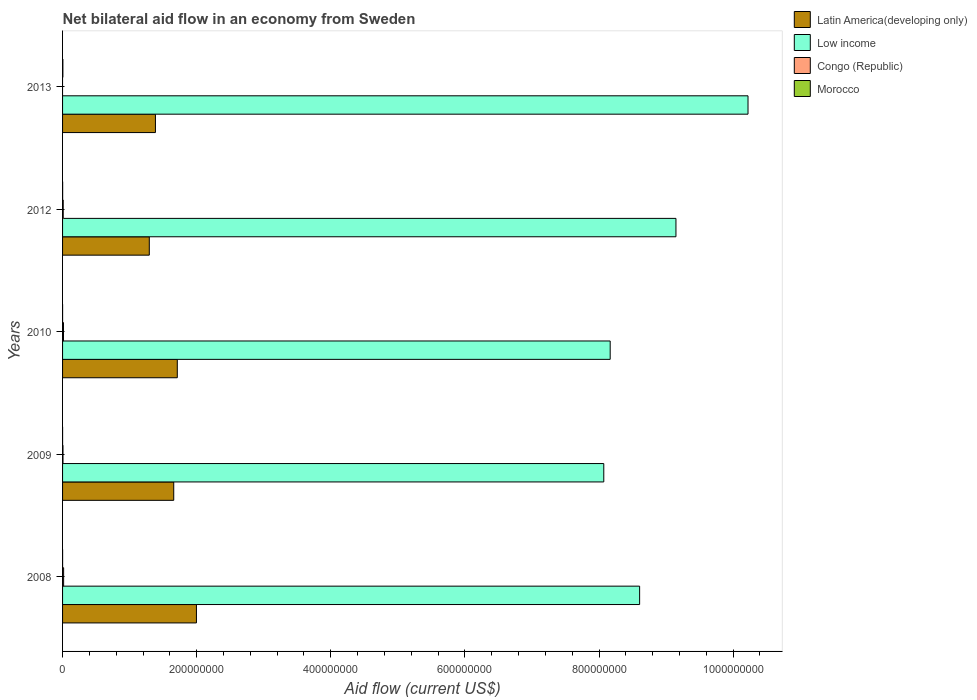How many different coloured bars are there?
Your response must be concise. 4. What is the label of the 4th group of bars from the top?
Provide a short and direct response. 2009. What is the net bilateral aid flow in Latin America(developing only) in 2010?
Offer a very short reply. 1.71e+08. Across all years, what is the maximum net bilateral aid flow in Latin America(developing only)?
Provide a short and direct response. 2.00e+08. Across all years, what is the minimum net bilateral aid flow in Latin America(developing only)?
Make the answer very short. 1.29e+08. What is the total net bilateral aid flow in Low income in the graph?
Your answer should be very brief. 4.42e+09. What is the difference between the net bilateral aid flow in Latin America(developing only) in 2009 and that in 2012?
Provide a short and direct response. 3.65e+07. What is the difference between the net bilateral aid flow in Congo (Republic) in 2010 and the net bilateral aid flow in Low income in 2012?
Your response must be concise. -9.13e+08. What is the average net bilateral aid flow in Congo (Republic) per year?
Make the answer very short. 9.08e+05. In the year 2008, what is the difference between the net bilateral aid flow in Congo (Republic) and net bilateral aid flow in Morocco?
Offer a terse response. 1.54e+06. What is the ratio of the net bilateral aid flow in Low income in 2009 to that in 2013?
Provide a succinct answer. 0.79. What is the difference between the highest and the lowest net bilateral aid flow in Morocco?
Offer a very short reply. 4.40e+05. In how many years, is the net bilateral aid flow in Low income greater than the average net bilateral aid flow in Low income taken over all years?
Your answer should be very brief. 2. How many bars are there?
Give a very brief answer. 19. What is the difference between two consecutive major ticks on the X-axis?
Keep it short and to the point. 2.00e+08. Does the graph contain any zero values?
Your answer should be very brief. Yes. Does the graph contain grids?
Your answer should be very brief. No. How are the legend labels stacked?
Ensure brevity in your answer.  Vertical. What is the title of the graph?
Make the answer very short. Net bilateral aid flow in an economy from Sweden. What is the Aid flow (current US$) in Latin America(developing only) in 2008?
Offer a terse response. 2.00e+08. What is the Aid flow (current US$) of Low income in 2008?
Your response must be concise. 8.61e+08. What is the Aid flow (current US$) in Congo (Republic) in 2008?
Ensure brevity in your answer.  1.57e+06. What is the Aid flow (current US$) of Latin America(developing only) in 2009?
Your answer should be compact. 1.66e+08. What is the Aid flow (current US$) in Low income in 2009?
Make the answer very short. 8.07e+08. What is the Aid flow (current US$) in Congo (Republic) in 2009?
Provide a short and direct response. 6.20e+05. What is the Aid flow (current US$) in Latin America(developing only) in 2010?
Provide a succinct answer. 1.71e+08. What is the Aid flow (current US$) of Low income in 2010?
Ensure brevity in your answer.  8.17e+08. What is the Aid flow (current US$) of Congo (Republic) in 2010?
Your response must be concise. 1.38e+06. What is the Aid flow (current US$) in Latin America(developing only) in 2012?
Keep it short and to the point. 1.29e+08. What is the Aid flow (current US$) in Low income in 2012?
Keep it short and to the point. 9.15e+08. What is the Aid flow (current US$) of Congo (Republic) in 2012?
Provide a short and direct response. 9.70e+05. What is the Aid flow (current US$) in Morocco in 2012?
Offer a terse response. 1.10e+05. What is the Aid flow (current US$) of Latin America(developing only) in 2013?
Your response must be concise. 1.38e+08. What is the Aid flow (current US$) in Low income in 2013?
Make the answer very short. 1.02e+09. Across all years, what is the maximum Aid flow (current US$) in Latin America(developing only)?
Your answer should be very brief. 2.00e+08. Across all years, what is the maximum Aid flow (current US$) in Low income?
Give a very brief answer. 1.02e+09. Across all years, what is the maximum Aid flow (current US$) in Congo (Republic)?
Your response must be concise. 1.57e+06. Across all years, what is the maximum Aid flow (current US$) of Morocco?
Your answer should be compact. 4.50e+05. Across all years, what is the minimum Aid flow (current US$) of Latin America(developing only)?
Provide a short and direct response. 1.29e+08. Across all years, what is the minimum Aid flow (current US$) in Low income?
Give a very brief answer. 8.07e+08. Across all years, what is the minimum Aid flow (current US$) of Morocco?
Your response must be concise. 10000. What is the total Aid flow (current US$) in Latin America(developing only) in the graph?
Give a very brief answer. 8.04e+08. What is the total Aid flow (current US$) of Low income in the graph?
Offer a terse response. 4.42e+09. What is the total Aid flow (current US$) of Congo (Republic) in the graph?
Make the answer very short. 4.54e+06. What is the total Aid flow (current US$) of Morocco in the graph?
Make the answer very short. 6.20e+05. What is the difference between the Aid flow (current US$) in Latin America(developing only) in 2008 and that in 2009?
Your answer should be compact. 3.38e+07. What is the difference between the Aid flow (current US$) in Low income in 2008 and that in 2009?
Provide a succinct answer. 5.34e+07. What is the difference between the Aid flow (current US$) in Congo (Republic) in 2008 and that in 2009?
Your answer should be compact. 9.50e+05. What is the difference between the Aid flow (current US$) of Latin America(developing only) in 2008 and that in 2010?
Offer a terse response. 2.85e+07. What is the difference between the Aid flow (current US$) in Low income in 2008 and that in 2010?
Your answer should be compact. 4.39e+07. What is the difference between the Aid flow (current US$) in Congo (Republic) in 2008 and that in 2010?
Give a very brief answer. 1.90e+05. What is the difference between the Aid flow (current US$) in Latin America(developing only) in 2008 and that in 2012?
Offer a very short reply. 7.03e+07. What is the difference between the Aid flow (current US$) of Low income in 2008 and that in 2012?
Your response must be concise. -5.42e+07. What is the difference between the Aid flow (current US$) in Congo (Republic) in 2008 and that in 2012?
Your response must be concise. 6.00e+05. What is the difference between the Aid flow (current US$) of Latin America(developing only) in 2008 and that in 2013?
Provide a short and direct response. 6.11e+07. What is the difference between the Aid flow (current US$) of Low income in 2008 and that in 2013?
Your answer should be very brief. -1.62e+08. What is the difference between the Aid flow (current US$) in Morocco in 2008 and that in 2013?
Provide a succinct answer. -4.20e+05. What is the difference between the Aid flow (current US$) in Latin America(developing only) in 2009 and that in 2010?
Keep it short and to the point. -5.31e+06. What is the difference between the Aid flow (current US$) in Low income in 2009 and that in 2010?
Make the answer very short. -9.55e+06. What is the difference between the Aid flow (current US$) in Congo (Republic) in 2009 and that in 2010?
Your response must be concise. -7.60e+05. What is the difference between the Aid flow (current US$) in Morocco in 2009 and that in 2010?
Make the answer very short. -10000. What is the difference between the Aid flow (current US$) in Latin America(developing only) in 2009 and that in 2012?
Provide a succinct answer. 3.65e+07. What is the difference between the Aid flow (current US$) in Low income in 2009 and that in 2012?
Offer a terse response. -1.08e+08. What is the difference between the Aid flow (current US$) of Congo (Republic) in 2009 and that in 2012?
Your response must be concise. -3.50e+05. What is the difference between the Aid flow (current US$) of Morocco in 2009 and that in 2012?
Make the answer very short. -1.00e+05. What is the difference between the Aid flow (current US$) in Latin America(developing only) in 2009 and that in 2013?
Your answer should be very brief. 2.73e+07. What is the difference between the Aid flow (current US$) in Low income in 2009 and that in 2013?
Provide a succinct answer. -2.15e+08. What is the difference between the Aid flow (current US$) of Morocco in 2009 and that in 2013?
Keep it short and to the point. -4.40e+05. What is the difference between the Aid flow (current US$) in Latin America(developing only) in 2010 and that in 2012?
Keep it short and to the point. 4.18e+07. What is the difference between the Aid flow (current US$) in Low income in 2010 and that in 2012?
Offer a very short reply. -9.81e+07. What is the difference between the Aid flow (current US$) in Congo (Republic) in 2010 and that in 2012?
Offer a terse response. 4.10e+05. What is the difference between the Aid flow (current US$) in Morocco in 2010 and that in 2012?
Your answer should be very brief. -9.00e+04. What is the difference between the Aid flow (current US$) of Latin America(developing only) in 2010 and that in 2013?
Provide a short and direct response. 3.26e+07. What is the difference between the Aid flow (current US$) of Low income in 2010 and that in 2013?
Your answer should be very brief. -2.06e+08. What is the difference between the Aid flow (current US$) in Morocco in 2010 and that in 2013?
Give a very brief answer. -4.30e+05. What is the difference between the Aid flow (current US$) in Latin America(developing only) in 2012 and that in 2013?
Ensure brevity in your answer.  -9.17e+06. What is the difference between the Aid flow (current US$) of Low income in 2012 and that in 2013?
Your answer should be compact. -1.07e+08. What is the difference between the Aid flow (current US$) in Latin America(developing only) in 2008 and the Aid flow (current US$) in Low income in 2009?
Make the answer very short. -6.07e+08. What is the difference between the Aid flow (current US$) of Latin America(developing only) in 2008 and the Aid flow (current US$) of Congo (Republic) in 2009?
Offer a terse response. 1.99e+08. What is the difference between the Aid flow (current US$) in Latin America(developing only) in 2008 and the Aid flow (current US$) in Morocco in 2009?
Keep it short and to the point. 2.00e+08. What is the difference between the Aid flow (current US$) in Low income in 2008 and the Aid flow (current US$) in Congo (Republic) in 2009?
Give a very brief answer. 8.60e+08. What is the difference between the Aid flow (current US$) in Low income in 2008 and the Aid flow (current US$) in Morocco in 2009?
Provide a succinct answer. 8.61e+08. What is the difference between the Aid flow (current US$) in Congo (Republic) in 2008 and the Aid flow (current US$) in Morocco in 2009?
Give a very brief answer. 1.56e+06. What is the difference between the Aid flow (current US$) in Latin America(developing only) in 2008 and the Aid flow (current US$) in Low income in 2010?
Your answer should be very brief. -6.17e+08. What is the difference between the Aid flow (current US$) of Latin America(developing only) in 2008 and the Aid flow (current US$) of Congo (Republic) in 2010?
Your answer should be compact. 1.98e+08. What is the difference between the Aid flow (current US$) in Latin America(developing only) in 2008 and the Aid flow (current US$) in Morocco in 2010?
Offer a very short reply. 2.00e+08. What is the difference between the Aid flow (current US$) of Low income in 2008 and the Aid flow (current US$) of Congo (Republic) in 2010?
Your answer should be compact. 8.59e+08. What is the difference between the Aid flow (current US$) of Low income in 2008 and the Aid flow (current US$) of Morocco in 2010?
Your answer should be compact. 8.61e+08. What is the difference between the Aid flow (current US$) of Congo (Republic) in 2008 and the Aid flow (current US$) of Morocco in 2010?
Provide a succinct answer. 1.55e+06. What is the difference between the Aid flow (current US$) in Latin America(developing only) in 2008 and the Aid flow (current US$) in Low income in 2012?
Give a very brief answer. -7.15e+08. What is the difference between the Aid flow (current US$) of Latin America(developing only) in 2008 and the Aid flow (current US$) of Congo (Republic) in 2012?
Provide a succinct answer. 1.99e+08. What is the difference between the Aid flow (current US$) of Latin America(developing only) in 2008 and the Aid flow (current US$) of Morocco in 2012?
Offer a terse response. 2.00e+08. What is the difference between the Aid flow (current US$) in Low income in 2008 and the Aid flow (current US$) in Congo (Republic) in 2012?
Offer a very short reply. 8.60e+08. What is the difference between the Aid flow (current US$) of Low income in 2008 and the Aid flow (current US$) of Morocco in 2012?
Provide a succinct answer. 8.60e+08. What is the difference between the Aid flow (current US$) of Congo (Republic) in 2008 and the Aid flow (current US$) of Morocco in 2012?
Offer a terse response. 1.46e+06. What is the difference between the Aid flow (current US$) of Latin America(developing only) in 2008 and the Aid flow (current US$) of Low income in 2013?
Ensure brevity in your answer.  -8.23e+08. What is the difference between the Aid flow (current US$) of Latin America(developing only) in 2008 and the Aid flow (current US$) of Morocco in 2013?
Provide a short and direct response. 1.99e+08. What is the difference between the Aid flow (current US$) of Low income in 2008 and the Aid flow (current US$) of Morocco in 2013?
Your answer should be very brief. 8.60e+08. What is the difference between the Aid flow (current US$) of Congo (Republic) in 2008 and the Aid flow (current US$) of Morocco in 2013?
Provide a succinct answer. 1.12e+06. What is the difference between the Aid flow (current US$) of Latin America(developing only) in 2009 and the Aid flow (current US$) of Low income in 2010?
Offer a very short reply. -6.51e+08. What is the difference between the Aid flow (current US$) of Latin America(developing only) in 2009 and the Aid flow (current US$) of Congo (Republic) in 2010?
Your answer should be compact. 1.64e+08. What is the difference between the Aid flow (current US$) of Latin America(developing only) in 2009 and the Aid flow (current US$) of Morocco in 2010?
Offer a very short reply. 1.66e+08. What is the difference between the Aid flow (current US$) in Low income in 2009 and the Aid flow (current US$) in Congo (Republic) in 2010?
Give a very brief answer. 8.06e+08. What is the difference between the Aid flow (current US$) in Low income in 2009 and the Aid flow (current US$) in Morocco in 2010?
Ensure brevity in your answer.  8.07e+08. What is the difference between the Aid flow (current US$) in Congo (Republic) in 2009 and the Aid flow (current US$) in Morocco in 2010?
Ensure brevity in your answer.  6.00e+05. What is the difference between the Aid flow (current US$) of Latin America(developing only) in 2009 and the Aid flow (current US$) of Low income in 2012?
Offer a terse response. -7.49e+08. What is the difference between the Aid flow (current US$) in Latin America(developing only) in 2009 and the Aid flow (current US$) in Congo (Republic) in 2012?
Offer a very short reply. 1.65e+08. What is the difference between the Aid flow (current US$) in Latin America(developing only) in 2009 and the Aid flow (current US$) in Morocco in 2012?
Your response must be concise. 1.66e+08. What is the difference between the Aid flow (current US$) in Low income in 2009 and the Aid flow (current US$) in Congo (Republic) in 2012?
Make the answer very short. 8.06e+08. What is the difference between the Aid flow (current US$) of Low income in 2009 and the Aid flow (current US$) of Morocco in 2012?
Provide a short and direct response. 8.07e+08. What is the difference between the Aid flow (current US$) of Congo (Republic) in 2009 and the Aid flow (current US$) of Morocco in 2012?
Provide a short and direct response. 5.10e+05. What is the difference between the Aid flow (current US$) in Latin America(developing only) in 2009 and the Aid flow (current US$) in Low income in 2013?
Offer a very short reply. -8.56e+08. What is the difference between the Aid flow (current US$) of Latin America(developing only) in 2009 and the Aid flow (current US$) of Morocco in 2013?
Offer a very short reply. 1.65e+08. What is the difference between the Aid flow (current US$) in Low income in 2009 and the Aid flow (current US$) in Morocco in 2013?
Offer a terse response. 8.07e+08. What is the difference between the Aid flow (current US$) of Congo (Republic) in 2009 and the Aid flow (current US$) of Morocco in 2013?
Make the answer very short. 1.70e+05. What is the difference between the Aid flow (current US$) of Latin America(developing only) in 2010 and the Aid flow (current US$) of Low income in 2012?
Give a very brief answer. -7.44e+08. What is the difference between the Aid flow (current US$) of Latin America(developing only) in 2010 and the Aid flow (current US$) of Congo (Republic) in 2012?
Your answer should be compact. 1.70e+08. What is the difference between the Aid flow (current US$) in Latin America(developing only) in 2010 and the Aid flow (current US$) in Morocco in 2012?
Provide a succinct answer. 1.71e+08. What is the difference between the Aid flow (current US$) of Low income in 2010 and the Aid flow (current US$) of Congo (Republic) in 2012?
Your answer should be compact. 8.16e+08. What is the difference between the Aid flow (current US$) in Low income in 2010 and the Aid flow (current US$) in Morocco in 2012?
Keep it short and to the point. 8.17e+08. What is the difference between the Aid flow (current US$) in Congo (Republic) in 2010 and the Aid flow (current US$) in Morocco in 2012?
Your answer should be compact. 1.27e+06. What is the difference between the Aid flow (current US$) in Latin America(developing only) in 2010 and the Aid flow (current US$) in Low income in 2013?
Your answer should be compact. -8.51e+08. What is the difference between the Aid flow (current US$) in Latin America(developing only) in 2010 and the Aid flow (current US$) in Morocco in 2013?
Your answer should be compact. 1.71e+08. What is the difference between the Aid flow (current US$) in Low income in 2010 and the Aid flow (current US$) in Morocco in 2013?
Offer a terse response. 8.16e+08. What is the difference between the Aid flow (current US$) in Congo (Republic) in 2010 and the Aid flow (current US$) in Morocco in 2013?
Provide a succinct answer. 9.30e+05. What is the difference between the Aid flow (current US$) of Latin America(developing only) in 2012 and the Aid flow (current US$) of Low income in 2013?
Offer a very short reply. -8.93e+08. What is the difference between the Aid flow (current US$) of Latin America(developing only) in 2012 and the Aid flow (current US$) of Morocco in 2013?
Your response must be concise. 1.29e+08. What is the difference between the Aid flow (current US$) of Low income in 2012 and the Aid flow (current US$) of Morocco in 2013?
Give a very brief answer. 9.14e+08. What is the difference between the Aid flow (current US$) in Congo (Republic) in 2012 and the Aid flow (current US$) in Morocco in 2013?
Ensure brevity in your answer.  5.20e+05. What is the average Aid flow (current US$) in Latin America(developing only) per year?
Your response must be concise. 1.61e+08. What is the average Aid flow (current US$) in Low income per year?
Provide a succinct answer. 8.84e+08. What is the average Aid flow (current US$) in Congo (Republic) per year?
Provide a short and direct response. 9.08e+05. What is the average Aid flow (current US$) of Morocco per year?
Provide a short and direct response. 1.24e+05. In the year 2008, what is the difference between the Aid flow (current US$) in Latin America(developing only) and Aid flow (current US$) in Low income?
Your answer should be very brief. -6.61e+08. In the year 2008, what is the difference between the Aid flow (current US$) of Latin America(developing only) and Aid flow (current US$) of Congo (Republic)?
Your answer should be very brief. 1.98e+08. In the year 2008, what is the difference between the Aid flow (current US$) in Latin America(developing only) and Aid flow (current US$) in Morocco?
Offer a terse response. 2.00e+08. In the year 2008, what is the difference between the Aid flow (current US$) of Low income and Aid flow (current US$) of Congo (Republic)?
Your response must be concise. 8.59e+08. In the year 2008, what is the difference between the Aid flow (current US$) in Low income and Aid flow (current US$) in Morocco?
Provide a short and direct response. 8.61e+08. In the year 2008, what is the difference between the Aid flow (current US$) of Congo (Republic) and Aid flow (current US$) of Morocco?
Make the answer very short. 1.54e+06. In the year 2009, what is the difference between the Aid flow (current US$) of Latin America(developing only) and Aid flow (current US$) of Low income?
Your answer should be very brief. -6.41e+08. In the year 2009, what is the difference between the Aid flow (current US$) of Latin America(developing only) and Aid flow (current US$) of Congo (Republic)?
Keep it short and to the point. 1.65e+08. In the year 2009, what is the difference between the Aid flow (current US$) of Latin America(developing only) and Aid flow (current US$) of Morocco?
Your answer should be very brief. 1.66e+08. In the year 2009, what is the difference between the Aid flow (current US$) in Low income and Aid flow (current US$) in Congo (Republic)?
Keep it short and to the point. 8.06e+08. In the year 2009, what is the difference between the Aid flow (current US$) in Low income and Aid flow (current US$) in Morocco?
Give a very brief answer. 8.07e+08. In the year 2010, what is the difference between the Aid flow (current US$) in Latin America(developing only) and Aid flow (current US$) in Low income?
Give a very brief answer. -6.46e+08. In the year 2010, what is the difference between the Aid flow (current US$) of Latin America(developing only) and Aid flow (current US$) of Congo (Republic)?
Provide a succinct answer. 1.70e+08. In the year 2010, what is the difference between the Aid flow (current US$) of Latin America(developing only) and Aid flow (current US$) of Morocco?
Make the answer very short. 1.71e+08. In the year 2010, what is the difference between the Aid flow (current US$) in Low income and Aid flow (current US$) in Congo (Republic)?
Keep it short and to the point. 8.15e+08. In the year 2010, what is the difference between the Aid flow (current US$) of Low income and Aid flow (current US$) of Morocco?
Your response must be concise. 8.17e+08. In the year 2010, what is the difference between the Aid flow (current US$) of Congo (Republic) and Aid flow (current US$) of Morocco?
Give a very brief answer. 1.36e+06. In the year 2012, what is the difference between the Aid flow (current US$) in Latin America(developing only) and Aid flow (current US$) in Low income?
Ensure brevity in your answer.  -7.85e+08. In the year 2012, what is the difference between the Aid flow (current US$) of Latin America(developing only) and Aid flow (current US$) of Congo (Republic)?
Make the answer very short. 1.28e+08. In the year 2012, what is the difference between the Aid flow (current US$) of Latin America(developing only) and Aid flow (current US$) of Morocco?
Keep it short and to the point. 1.29e+08. In the year 2012, what is the difference between the Aid flow (current US$) in Low income and Aid flow (current US$) in Congo (Republic)?
Ensure brevity in your answer.  9.14e+08. In the year 2012, what is the difference between the Aid flow (current US$) of Low income and Aid flow (current US$) of Morocco?
Keep it short and to the point. 9.15e+08. In the year 2012, what is the difference between the Aid flow (current US$) in Congo (Republic) and Aid flow (current US$) in Morocco?
Make the answer very short. 8.60e+05. In the year 2013, what is the difference between the Aid flow (current US$) in Latin America(developing only) and Aid flow (current US$) in Low income?
Make the answer very short. -8.84e+08. In the year 2013, what is the difference between the Aid flow (current US$) in Latin America(developing only) and Aid flow (current US$) in Morocco?
Your answer should be compact. 1.38e+08. In the year 2013, what is the difference between the Aid flow (current US$) in Low income and Aid flow (current US$) in Morocco?
Provide a succinct answer. 1.02e+09. What is the ratio of the Aid flow (current US$) in Latin America(developing only) in 2008 to that in 2009?
Give a very brief answer. 1.2. What is the ratio of the Aid flow (current US$) of Low income in 2008 to that in 2009?
Your answer should be compact. 1.07. What is the ratio of the Aid flow (current US$) in Congo (Republic) in 2008 to that in 2009?
Ensure brevity in your answer.  2.53. What is the ratio of the Aid flow (current US$) of Latin America(developing only) in 2008 to that in 2010?
Give a very brief answer. 1.17. What is the ratio of the Aid flow (current US$) in Low income in 2008 to that in 2010?
Offer a terse response. 1.05. What is the ratio of the Aid flow (current US$) of Congo (Republic) in 2008 to that in 2010?
Provide a succinct answer. 1.14. What is the ratio of the Aid flow (current US$) of Latin America(developing only) in 2008 to that in 2012?
Your answer should be compact. 1.54. What is the ratio of the Aid flow (current US$) of Low income in 2008 to that in 2012?
Offer a very short reply. 0.94. What is the ratio of the Aid flow (current US$) of Congo (Republic) in 2008 to that in 2012?
Provide a short and direct response. 1.62. What is the ratio of the Aid flow (current US$) in Morocco in 2008 to that in 2012?
Your response must be concise. 0.27. What is the ratio of the Aid flow (current US$) of Latin America(developing only) in 2008 to that in 2013?
Make the answer very short. 1.44. What is the ratio of the Aid flow (current US$) of Low income in 2008 to that in 2013?
Offer a terse response. 0.84. What is the ratio of the Aid flow (current US$) in Morocco in 2008 to that in 2013?
Make the answer very short. 0.07. What is the ratio of the Aid flow (current US$) of Low income in 2009 to that in 2010?
Provide a succinct answer. 0.99. What is the ratio of the Aid flow (current US$) of Congo (Republic) in 2009 to that in 2010?
Make the answer very short. 0.45. What is the ratio of the Aid flow (current US$) of Latin America(developing only) in 2009 to that in 2012?
Give a very brief answer. 1.28. What is the ratio of the Aid flow (current US$) in Low income in 2009 to that in 2012?
Your answer should be compact. 0.88. What is the ratio of the Aid flow (current US$) in Congo (Republic) in 2009 to that in 2012?
Give a very brief answer. 0.64. What is the ratio of the Aid flow (current US$) in Morocco in 2009 to that in 2012?
Keep it short and to the point. 0.09. What is the ratio of the Aid flow (current US$) of Latin America(developing only) in 2009 to that in 2013?
Provide a short and direct response. 1.2. What is the ratio of the Aid flow (current US$) in Low income in 2009 to that in 2013?
Ensure brevity in your answer.  0.79. What is the ratio of the Aid flow (current US$) of Morocco in 2009 to that in 2013?
Provide a succinct answer. 0.02. What is the ratio of the Aid flow (current US$) in Latin America(developing only) in 2010 to that in 2012?
Ensure brevity in your answer.  1.32. What is the ratio of the Aid flow (current US$) in Low income in 2010 to that in 2012?
Ensure brevity in your answer.  0.89. What is the ratio of the Aid flow (current US$) in Congo (Republic) in 2010 to that in 2012?
Offer a terse response. 1.42. What is the ratio of the Aid flow (current US$) in Morocco in 2010 to that in 2012?
Ensure brevity in your answer.  0.18. What is the ratio of the Aid flow (current US$) in Latin America(developing only) in 2010 to that in 2013?
Provide a succinct answer. 1.24. What is the ratio of the Aid flow (current US$) in Low income in 2010 to that in 2013?
Offer a terse response. 0.8. What is the ratio of the Aid flow (current US$) in Morocco in 2010 to that in 2013?
Offer a very short reply. 0.04. What is the ratio of the Aid flow (current US$) in Latin America(developing only) in 2012 to that in 2013?
Offer a terse response. 0.93. What is the ratio of the Aid flow (current US$) of Low income in 2012 to that in 2013?
Provide a short and direct response. 0.89. What is the ratio of the Aid flow (current US$) of Morocco in 2012 to that in 2013?
Offer a very short reply. 0.24. What is the difference between the highest and the second highest Aid flow (current US$) of Latin America(developing only)?
Your answer should be compact. 2.85e+07. What is the difference between the highest and the second highest Aid flow (current US$) in Low income?
Ensure brevity in your answer.  1.07e+08. What is the difference between the highest and the second highest Aid flow (current US$) of Morocco?
Your response must be concise. 3.40e+05. What is the difference between the highest and the lowest Aid flow (current US$) of Latin America(developing only)?
Your answer should be very brief. 7.03e+07. What is the difference between the highest and the lowest Aid flow (current US$) of Low income?
Provide a succinct answer. 2.15e+08. What is the difference between the highest and the lowest Aid flow (current US$) of Congo (Republic)?
Provide a succinct answer. 1.57e+06. What is the difference between the highest and the lowest Aid flow (current US$) in Morocco?
Offer a very short reply. 4.40e+05. 